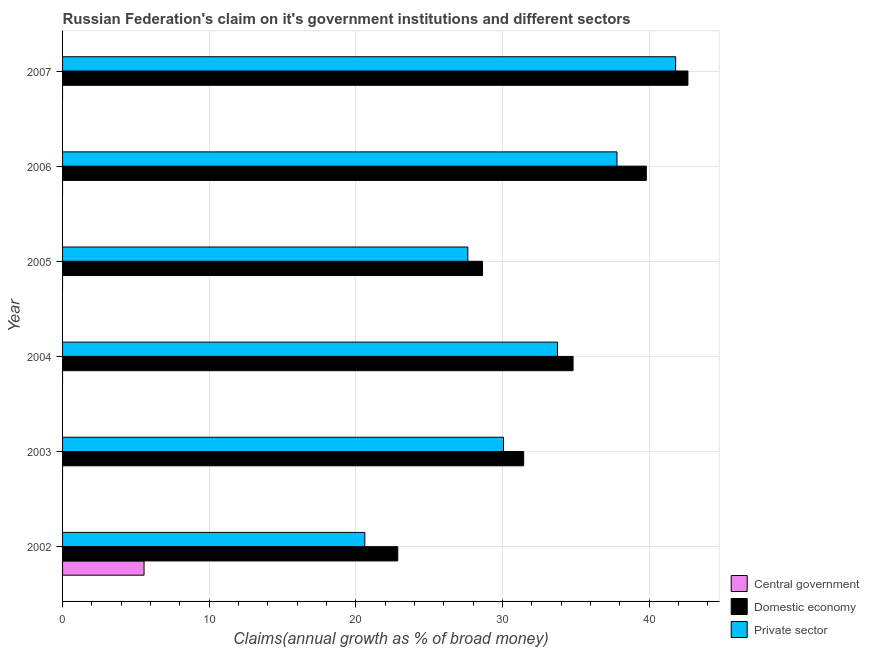How many groups of bars are there?
Make the answer very short. 6. How many bars are there on the 4th tick from the top?
Offer a terse response. 2. How many bars are there on the 1st tick from the bottom?
Keep it short and to the point. 3. In how many cases, is the number of bars for a given year not equal to the number of legend labels?
Give a very brief answer. 5. What is the percentage of claim on the central government in 2002?
Offer a terse response. 5.56. Across all years, what is the maximum percentage of claim on the private sector?
Provide a succinct answer. 41.8. Across all years, what is the minimum percentage of claim on the domestic economy?
Provide a succinct answer. 22.86. In which year was the percentage of claim on the private sector maximum?
Your answer should be very brief. 2007. What is the total percentage of claim on the domestic economy in the graph?
Keep it short and to the point. 200.18. What is the difference between the percentage of claim on the domestic economy in 2002 and that in 2006?
Provide a succinct answer. -16.95. What is the difference between the percentage of claim on the domestic economy in 2005 and the percentage of claim on the private sector in 2002?
Offer a very short reply. 8.02. What is the average percentage of claim on the central government per year?
Provide a succinct answer. 0.93. In the year 2002, what is the difference between the percentage of claim on the private sector and percentage of claim on the domestic economy?
Give a very brief answer. -2.25. In how many years, is the percentage of claim on the domestic economy greater than 40 %?
Your answer should be compact. 1. What is the ratio of the percentage of claim on the domestic economy in 2003 to that in 2005?
Keep it short and to the point. 1.1. Is the difference between the percentage of claim on the private sector in 2002 and 2003 greater than the difference between the percentage of claim on the domestic economy in 2002 and 2003?
Provide a short and direct response. No. What is the difference between the highest and the second highest percentage of claim on the domestic economy?
Offer a very short reply. 2.84. What is the difference between the highest and the lowest percentage of claim on the domestic economy?
Give a very brief answer. 19.78. In how many years, is the percentage of claim on the central government greater than the average percentage of claim on the central government taken over all years?
Offer a terse response. 1. Is it the case that in every year, the sum of the percentage of claim on the central government and percentage of claim on the domestic economy is greater than the percentage of claim on the private sector?
Your answer should be very brief. Yes. How many years are there in the graph?
Provide a short and direct response. 6. What is the difference between two consecutive major ticks on the X-axis?
Give a very brief answer. 10. Does the graph contain any zero values?
Give a very brief answer. Yes. Does the graph contain grids?
Offer a very short reply. Yes. Where does the legend appear in the graph?
Provide a succinct answer. Bottom right. How many legend labels are there?
Your answer should be very brief. 3. What is the title of the graph?
Provide a short and direct response. Russian Federation's claim on it's government institutions and different sectors. Does "Infant(female)" appear as one of the legend labels in the graph?
Your answer should be very brief. No. What is the label or title of the X-axis?
Provide a succinct answer. Claims(annual growth as % of broad money). What is the label or title of the Y-axis?
Your response must be concise. Year. What is the Claims(annual growth as % of broad money) of Central government in 2002?
Your answer should be compact. 5.56. What is the Claims(annual growth as % of broad money) of Domestic economy in 2002?
Your answer should be compact. 22.86. What is the Claims(annual growth as % of broad money) of Private sector in 2002?
Offer a terse response. 20.61. What is the Claims(annual growth as % of broad money) in Central government in 2003?
Give a very brief answer. 0. What is the Claims(annual growth as % of broad money) in Domestic economy in 2003?
Your response must be concise. 31.44. What is the Claims(annual growth as % of broad money) in Private sector in 2003?
Your answer should be compact. 30.06. What is the Claims(annual growth as % of broad money) of Domestic economy in 2004?
Give a very brief answer. 34.81. What is the Claims(annual growth as % of broad money) of Private sector in 2004?
Your answer should be compact. 33.75. What is the Claims(annual growth as % of broad money) in Domestic economy in 2005?
Your answer should be very brief. 28.63. What is the Claims(annual growth as % of broad money) in Private sector in 2005?
Provide a succinct answer. 27.63. What is the Claims(annual growth as % of broad money) in Domestic economy in 2006?
Offer a terse response. 39.8. What is the Claims(annual growth as % of broad money) of Private sector in 2006?
Provide a succinct answer. 37.8. What is the Claims(annual growth as % of broad money) in Central government in 2007?
Keep it short and to the point. 0. What is the Claims(annual growth as % of broad money) in Domestic economy in 2007?
Offer a very short reply. 42.64. What is the Claims(annual growth as % of broad money) of Private sector in 2007?
Your answer should be compact. 41.8. Across all years, what is the maximum Claims(annual growth as % of broad money) of Central government?
Keep it short and to the point. 5.56. Across all years, what is the maximum Claims(annual growth as % of broad money) of Domestic economy?
Provide a short and direct response. 42.64. Across all years, what is the maximum Claims(annual growth as % of broad money) in Private sector?
Offer a very short reply. 41.8. Across all years, what is the minimum Claims(annual growth as % of broad money) in Domestic economy?
Ensure brevity in your answer.  22.86. Across all years, what is the minimum Claims(annual growth as % of broad money) in Private sector?
Provide a short and direct response. 20.61. What is the total Claims(annual growth as % of broad money) in Central government in the graph?
Your answer should be very brief. 5.56. What is the total Claims(annual growth as % of broad money) of Domestic economy in the graph?
Ensure brevity in your answer.  200.18. What is the total Claims(annual growth as % of broad money) of Private sector in the graph?
Provide a succinct answer. 191.66. What is the difference between the Claims(annual growth as % of broad money) of Domestic economy in 2002 and that in 2003?
Provide a succinct answer. -8.59. What is the difference between the Claims(annual growth as % of broad money) of Private sector in 2002 and that in 2003?
Ensure brevity in your answer.  -9.45. What is the difference between the Claims(annual growth as % of broad money) in Domestic economy in 2002 and that in 2004?
Keep it short and to the point. -11.95. What is the difference between the Claims(annual growth as % of broad money) of Private sector in 2002 and that in 2004?
Offer a terse response. -13.14. What is the difference between the Claims(annual growth as % of broad money) of Domestic economy in 2002 and that in 2005?
Your answer should be compact. -5.78. What is the difference between the Claims(annual growth as % of broad money) in Private sector in 2002 and that in 2005?
Keep it short and to the point. -7.02. What is the difference between the Claims(annual growth as % of broad money) in Domestic economy in 2002 and that in 2006?
Your answer should be very brief. -16.95. What is the difference between the Claims(annual growth as % of broad money) in Private sector in 2002 and that in 2006?
Your response must be concise. -17.19. What is the difference between the Claims(annual growth as % of broad money) of Domestic economy in 2002 and that in 2007?
Offer a very short reply. -19.78. What is the difference between the Claims(annual growth as % of broad money) of Private sector in 2002 and that in 2007?
Make the answer very short. -21.19. What is the difference between the Claims(annual growth as % of broad money) in Domestic economy in 2003 and that in 2004?
Ensure brevity in your answer.  -3.37. What is the difference between the Claims(annual growth as % of broad money) of Private sector in 2003 and that in 2004?
Your response must be concise. -3.69. What is the difference between the Claims(annual growth as % of broad money) of Domestic economy in 2003 and that in 2005?
Ensure brevity in your answer.  2.81. What is the difference between the Claims(annual growth as % of broad money) in Private sector in 2003 and that in 2005?
Your answer should be compact. 2.43. What is the difference between the Claims(annual growth as % of broad money) of Domestic economy in 2003 and that in 2006?
Keep it short and to the point. -8.36. What is the difference between the Claims(annual growth as % of broad money) in Private sector in 2003 and that in 2006?
Keep it short and to the point. -7.74. What is the difference between the Claims(annual growth as % of broad money) in Domestic economy in 2003 and that in 2007?
Your answer should be very brief. -11.2. What is the difference between the Claims(annual growth as % of broad money) of Private sector in 2003 and that in 2007?
Ensure brevity in your answer.  -11.74. What is the difference between the Claims(annual growth as % of broad money) in Domestic economy in 2004 and that in 2005?
Provide a short and direct response. 6.17. What is the difference between the Claims(annual growth as % of broad money) of Private sector in 2004 and that in 2005?
Ensure brevity in your answer.  6.12. What is the difference between the Claims(annual growth as % of broad money) in Domestic economy in 2004 and that in 2006?
Offer a terse response. -4.99. What is the difference between the Claims(annual growth as % of broad money) in Private sector in 2004 and that in 2006?
Give a very brief answer. -4.06. What is the difference between the Claims(annual growth as % of broad money) in Domestic economy in 2004 and that in 2007?
Offer a terse response. -7.83. What is the difference between the Claims(annual growth as % of broad money) of Private sector in 2004 and that in 2007?
Your answer should be compact. -8.06. What is the difference between the Claims(annual growth as % of broad money) in Domestic economy in 2005 and that in 2006?
Ensure brevity in your answer.  -11.17. What is the difference between the Claims(annual growth as % of broad money) of Private sector in 2005 and that in 2006?
Provide a short and direct response. -10.17. What is the difference between the Claims(annual growth as % of broad money) in Domestic economy in 2005 and that in 2007?
Your answer should be compact. -14. What is the difference between the Claims(annual growth as % of broad money) of Private sector in 2005 and that in 2007?
Keep it short and to the point. -14.17. What is the difference between the Claims(annual growth as % of broad money) of Domestic economy in 2006 and that in 2007?
Provide a succinct answer. -2.84. What is the difference between the Claims(annual growth as % of broad money) in Private sector in 2006 and that in 2007?
Your response must be concise. -4. What is the difference between the Claims(annual growth as % of broad money) in Central government in 2002 and the Claims(annual growth as % of broad money) in Domestic economy in 2003?
Provide a short and direct response. -25.88. What is the difference between the Claims(annual growth as % of broad money) of Central government in 2002 and the Claims(annual growth as % of broad money) of Private sector in 2003?
Your response must be concise. -24.51. What is the difference between the Claims(annual growth as % of broad money) of Domestic economy in 2002 and the Claims(annual growth as % of broad money) of Private sector in 2003?
Keep it short and to the point. -7.21. What is the difference between the Claims(annual growth as % of broad money) in Central government in 2002 and the Claims(annual growth as % of broad money) in Domestic economy in 2004?
Your answer should be compact. -29.25. What is the difference between the Claims(annual growth as % of broad money) of Central government in 2002 and the Claims(annual growth as % of broad money) of Private sector in 2004?
Your answer should be compact. -28.19. What is the difference between the Claims(annual growth as % of broad money) of Domestic economy in 2002 and the Claims(annual growth as % of broad money) of Private sector in 2004?
Ensure brevity in your answer.  -10.89. What is the difference between the Claims(annual growth as % of broad money) of Central government in 2002 and the Claims(annual growth as % of broad money) of Domestic economy in 2005?
Provide a succinct answer. -23.08. What is the difference between the Claims(annual growth as % of broad money) in Central government in 2002 and the Claims(annual growth as % of broad money) in Private sector in 2005?
Make the answer very short. -22.08. What is the difference between the Claims(annual growth as % of broad money) of Domestic economy in 2002 and the Claims(annual growth as % of broad money) of Private sector in 2005?
Provide a succinct answer. -4.78. What is the difference between the Claims(annual growth as % of broad money) of Central government in 2002 and the Claims(annual growth as % of broad money) of Domestic economy in 2006?
Provide a short and direct response. -34.24. What is the difference between the Claims(annual growth as % of broad money) of Central government in 2002 and the Claims(annual growth as % of broad money) of Private sector in 2006?
Offer a terse response. -32.25. What is the difference between the Claims(annual growth as % of broad money) in Domestic economy in 2002 and the Claims(annual growth as % of broad money) in Private sector in 2006?
Keep it short and to the point. -14.95. What is the difference between the Claims(annual growth as % of broad money) of Central government in 2002 and the Claims(annual growth as % of broad money) of Domestic economy in 2007?
Your answer should be very brief. -37.08. What is the difference between the Claims(annual growth as % of broad money) in Central government in 2002 and the Claims(annual growth as % of broad money) in Private sector in 2007?
Provide a short and direct response. -36.25. What is the difference between the Claims(annual growth as % of broad money) in Domestic economy in 2002 and the Claims(annual growth as % of broad money) in Private sector in 2007?
Provide a succinct answer. -18.95. What is the difference between the Claims(annual growth as % of broad money) in Domestic economy in 2003 and the Claims(annual growth as % of broad money) in Private sector in 2004?
Offer a very short reply. -2.31. What is the difference between the Claims(annual growth as % of broad money) of Domestic economy in 2003 and the Claims(annual growth as % of broad money) of Private sector in 2005?
Offer a very short reply. 3.81. What is the difference between the Claims(annual growth as % of broad money) of Domestic economy in 2003 and the Claims(annual growth as % of broad money) of Private sector in 2006?
Provide a succinct answer. -6.36. What is the difference between the Claims(annual growth as % of broad money) in Domestic economy in 2003 and the Claims(annual growth as % of broad money) in Private sector in 2007?
Provide a short and direct response. -10.36. What is the difference between the Claims(annual growth as % of broad money) in Domestic economy in 2004 and the Claims(annual growth as % of broad money) in Private sector in 2005?
Your answer should be very brief. 7.18. What is the difference between the Claims(annual growth as % of broad money) of Domestic economy in 2004 and the Claims(annual growth as % of broad money) of Private sector in 2006?
Keep it short and to the point. -3. What is the difference between the Claims(annual growth as % of broad money) of Domestic economy in 2004 and the Claims(annual growth as % of broad money) of Private sector in 2007?
Your answer should be very brief. -7. What is the difference between the Claims(annual growth as % of broad money) of Domestic economy in 2005 and the Claims(annual growth as % of broad money) of Private sector in 2006?
Offer a terse response. -9.17. What is the difference between the Claims(annual growth as % of broad money) of Domestic economy in 2005 and the Claims(annual growth as % of broad money) of Private sector in 2007?
Provide a succinct answer. -13.17. What is the difference between the Claims(annual growth as % of broad money) in Domestic economy in 2006 and the Claims(annual growth as % of broad money) in Private sector in 2007?
Ensure brevity in your answer.  -2. What is the average Claims(annual growth as % of broad money) of Central government per year?
Your answer should be very brief. 0.93. What is the average Claims(annual growth as % of broad money) in Domestic economy per year?
Make the answer very short. 33.36. What is the average Claims(annual growth as % of broad money) of Private sector per year?
Give a very brief answer. 31.94. In the year 2002, what is the difference between the Claims(annual growth as % of broad money) in Central government and Claims(annual growth as % of broad money) in Domestic economy?
Provide a succinct answer. -17.3. In the year 2002, what is the difference between the Claims(annual growth as % of broad money) of Central government and Claims(annual growth as % of broad money) of Private sector?
Give a very brief answer. -15.05. In the year 2002, what is the difference between the Claims(annual growth as % of broad money) in Domestic economy and Claims(annual growth as % of broad money) in Private sector?
Give a very brief answer. 2.25. In the year 2003, what is the difference between the Claims(annual growth as % of broad money) of Domestic economy and Claims(annual growth as % of broad money) of Private sector?
Your answer should be very brief. 1.38. In the year 2004, what is the difference between the Claims(annual growth as % of broad money) in Domestic economy and Claims(annual growth as % of broad money) in Private sector?
Offer a very short reply. 1.06. In the year 2005, what is the difference between the Claims(annual growth as % of broad money) in Domestic economy and Claims(annual growth as % of broad money) in Private sector?
Offer a very short reply. 1. In the year 2006, what is the difference between the Claims(annual growth as % of broad money) of Domestic economy and Claims(annual growth as % of broad money) of Private sector?
Your answer should be compact. 2. In the year 2007, what is the difference between the Claims(annual growth as % of broad money) in Domestic economy and Claims(annual growth as % of broad money) in Private sector?
Your answer should be very brief. 0.84. What is the ratio of the Claims(annual growth as % of broad money) in Domestic economy in 2002 to that in 2003?
Give a very brief answer. 0.73. What is the ratio of the Claims(annual growth as % of broad money) of Private sector in 2002 to that in 2003?
Make the answer very short. 0.69. What is the ratio of the Claims(annual growth as % of broad money) of Domestic economy in 2002 to that in 2004?
Give a very brief answer. 0.66. What is the ratio of the Claims(annual growth as % of broad money) in Private sector in 2002 to that in 2004?
Offer a terse response. 0.61. What is the ratio of the Claims(annual growth as % of broad money) in Domestic economy in 2002 to that in 2005?
Make the answer very short. 0.8. What is the ratio of the Claims(annual growth as % of broad money) in Private sector in 2002 to that in 2005?
Your answer should be compact. 0.75. What is the ratio of the Claims(annual growth as % of broad money) of Domestic economy in 2002 to that in 2006?
Make the answer very short. 0.57. What is the ratio of the Claims(annual growth as % of broad money) of Private sector in 2002 to that in 2006?
Ensure brevity in your answer.  0.55. What is the ratio of the Claims(annual growth as % of broad money) of Domestic economy in 2002 to that in 2007?
Keep it short and to the point. 0.54. What is the ratio of the Claims(annual growth as % of broad money) of Private sector in 2002 to that in 2007?
Give a very brief answer. 0.49. What is the ratio of the Claims(annual growth as % of broad money) in Domestic economy in 2003 to that in 2004?
Make the answer very short. 0.9. What is the ratio of the Claims(annual growth as % of broad money) in Private sector in 2003 to that in 2004?
Offer a very short reply. 0.89. What is the ratio of the Claims(annual growth as % of broad money) of Domestic economy in 2003 to that in 2005?
Your answer should be very brief. 1.1. What is the ratio of the Claims(annual growth as % of broad money) in Private sector in 2003 to that in 2005?
Make the answer very short. 1.09. What is the ratio of the Claims(annual growth as % of broad money) in Domestic economy in 2003 to that in 2006?
Provide a short and direct response. 0.79. What is the ratio of the Claims(annual growth as % of broad money) of Private sector in 2003 to that in 2006?
Offer a very short reply. 0.8. What is the ratio of the Claims(annual growth as % of broad money) of Domestic economy in 2003 to that in 2007?
Give a very brief answer. 0.74. What is the ratio of the Claims(annual growth as % of broad money) in Private sector in 2003 to that in 2007?
Provide a succinct answer. 0.72. What is the ratio of the Claims(annual growth as % of broad money) in Domestic economy in 2004 to that in 2005?
Keep it short and to the point. 1.22. What is the ratio of the Claims(annual growth as % of broad money) in Private sector in 2004 to that in 2005?
Ensure brevity in your answer.  1.22. What is the ratio of the Claims(annual growth as % of broad money) in Domestic economy in 2004 to that in 2006?
Provide a short and direct response. 0.87. What is the ratio of the Claims(annual growth as % of broad money) of Private sector in 2004 to that in 2006?
Provide a short and direct response. 0.89. What is the ratio of the Claims(annual growth as % of broad money) of Domestic economy in 2004 to that in 2007?
Provide a short and direct response. 0.82. What is the ratio of the Claims(annual growth as % of broad money) of Private sector in 2004 to that in 2007?
Your response must be concise. 0.81. What is the ratio of the Claims(annual growth as % of broad money) in Domestic economy in 2005 to that in 2006?
Give a very brief answer. 0.72. What is the ratio of the Claims(annual growth as % of broad money) in Private sector in 2005 to that in 2006?
Your answer should be compact. 0.73. What is the ratio of the Claims(annual growth as % of broad money) of Domestic economy in 2005 to that in 2007?
Keep it short and to the point. 0.67. What is the ratio of the Claims(annual growth as % of broad money) of Private sector in 2005 to that in 2007?
Give a very brief answer. 0.66. What is the ratio of the Claims(annual growth as % of broad money) of Domestic economy in 2006 to that in 2007?
Offer a very short reply. 0.93. What is the ratio of the Claims(annual growth as % of broad money) in Private sector in 2006 to that in 2007?
Your response must be concise. 0.9. What is the difference between the highest and the second highest Claims(annual growth as % of broad money) in Domestic economy?
Give a very brief answer. 2.84. What is the difference between the highest and the second highest Claims(annual growth as % of broad money) of Private sector?
Provide a short and direct response. 4. What is the difference between the highest and the lowest Claims(annual growth as % of broad money) in Central government?
Provide a succinct answer. 5.56. What is the difference between the highest and the lowest Claims(annual growth as % of broad money) in Domestic economy?
Offer a very short reply. 19.78. What is the difference between the highest and the lowest Claims(annual growth as % of broad money) in Private sector?
Your response must be concise. 21.19. 